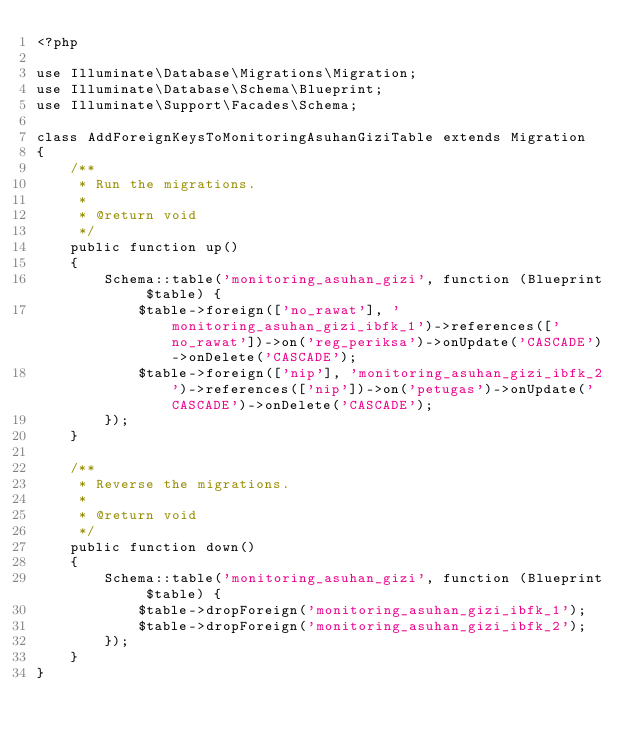Convert code to text. <code><loc_0><loc_0><loc_500><loc_500><_PHP_><?php

use Illuminate\Database\Migrations\Migration;
use Illuminate\Database\Schema\Blueprint;
use Illuminate\Support\Facades\Schema;

class AddForeignKeysToMonitoringAsuhanGiziTable extends Migration
{
    /**
     * Run the migrations.
     *
     * @return void
     */
    public function up()
    {
        Schema::table('monitoring_asuhan_gizi', function (Blueprint $table) {
            $table->foreign(['no_rawat'], 'monitoring_asuhan_gizi_ibfk_1')->references(['no_rawat'])->on('reg_periksa')->onUpdate('CASCADE')->onDelete('CASCADE');
            $table->foreign(['nip'], 'monitoring_asuhan_gizi_ibfk_2')->references(['nip'])->on('petugas')->onUpdate('CASCADE')->onDelete('CASCADE');
        });
    }

    /**
     * Reverse the migrations.
     *
     * @return void
     */
    public function down()
    {
        Schema::table('monitoring_asuhan_gizi', function (Blueprint $table) {
            $table->dropForeign('monitoring_asuhan_gizi_ibfk_1');
            $table->dropForeign('monitoring_asuhan_gizi_ibfk_2');
        });
    }
}
</code> 